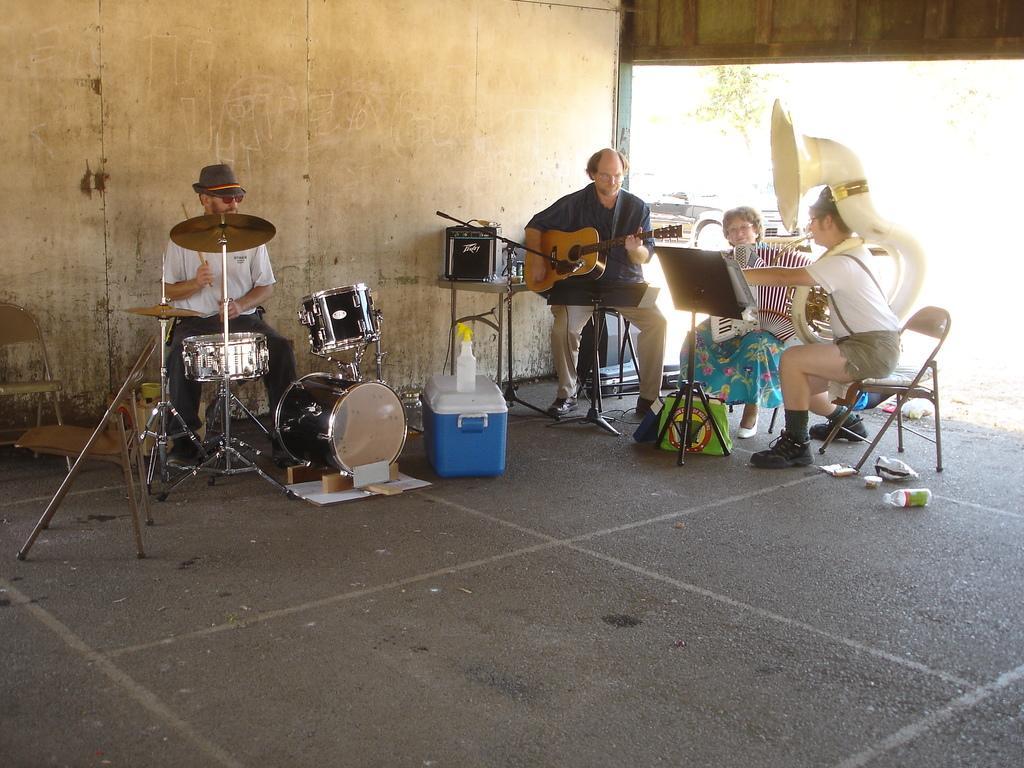Please provide a concise description of this image. In this image four people two people are playing musical instruments, the man on the left side is playing a drum, the man behind him is playing guitar we can see musical instruments like cymbal and drums here and there is a basket over here on right side woman is sitting on the chair and on the right side the man is pointing his hand towards something we can see bottles on the floor. 